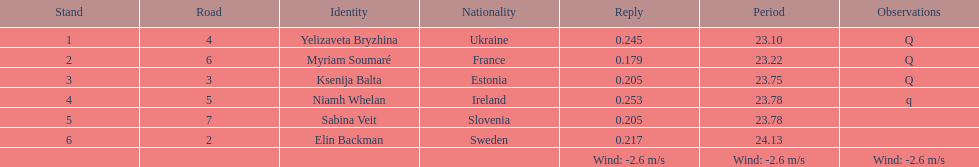Who came in following sabina veit's finish? Elin Backman. 